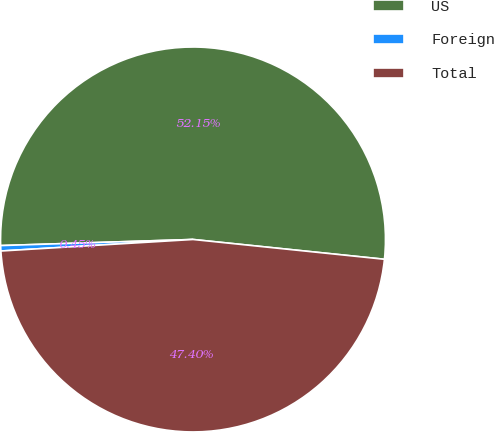Convert chart to OTSL. <chart><loc_0><loc_0><loc_500><loc_500><pie_chart><fcel>US<fcel>Foreign<fcel>Total<nl><fcel>52.14%<fcel>0.45%<fcel>47.4%<nl></chart> 